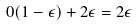<formula> <loc_0><loc_0><loc_500><loc_500>0 ( 1 - \epsilon ) + 2 \epsilon = 2 \epsilon</formula> 